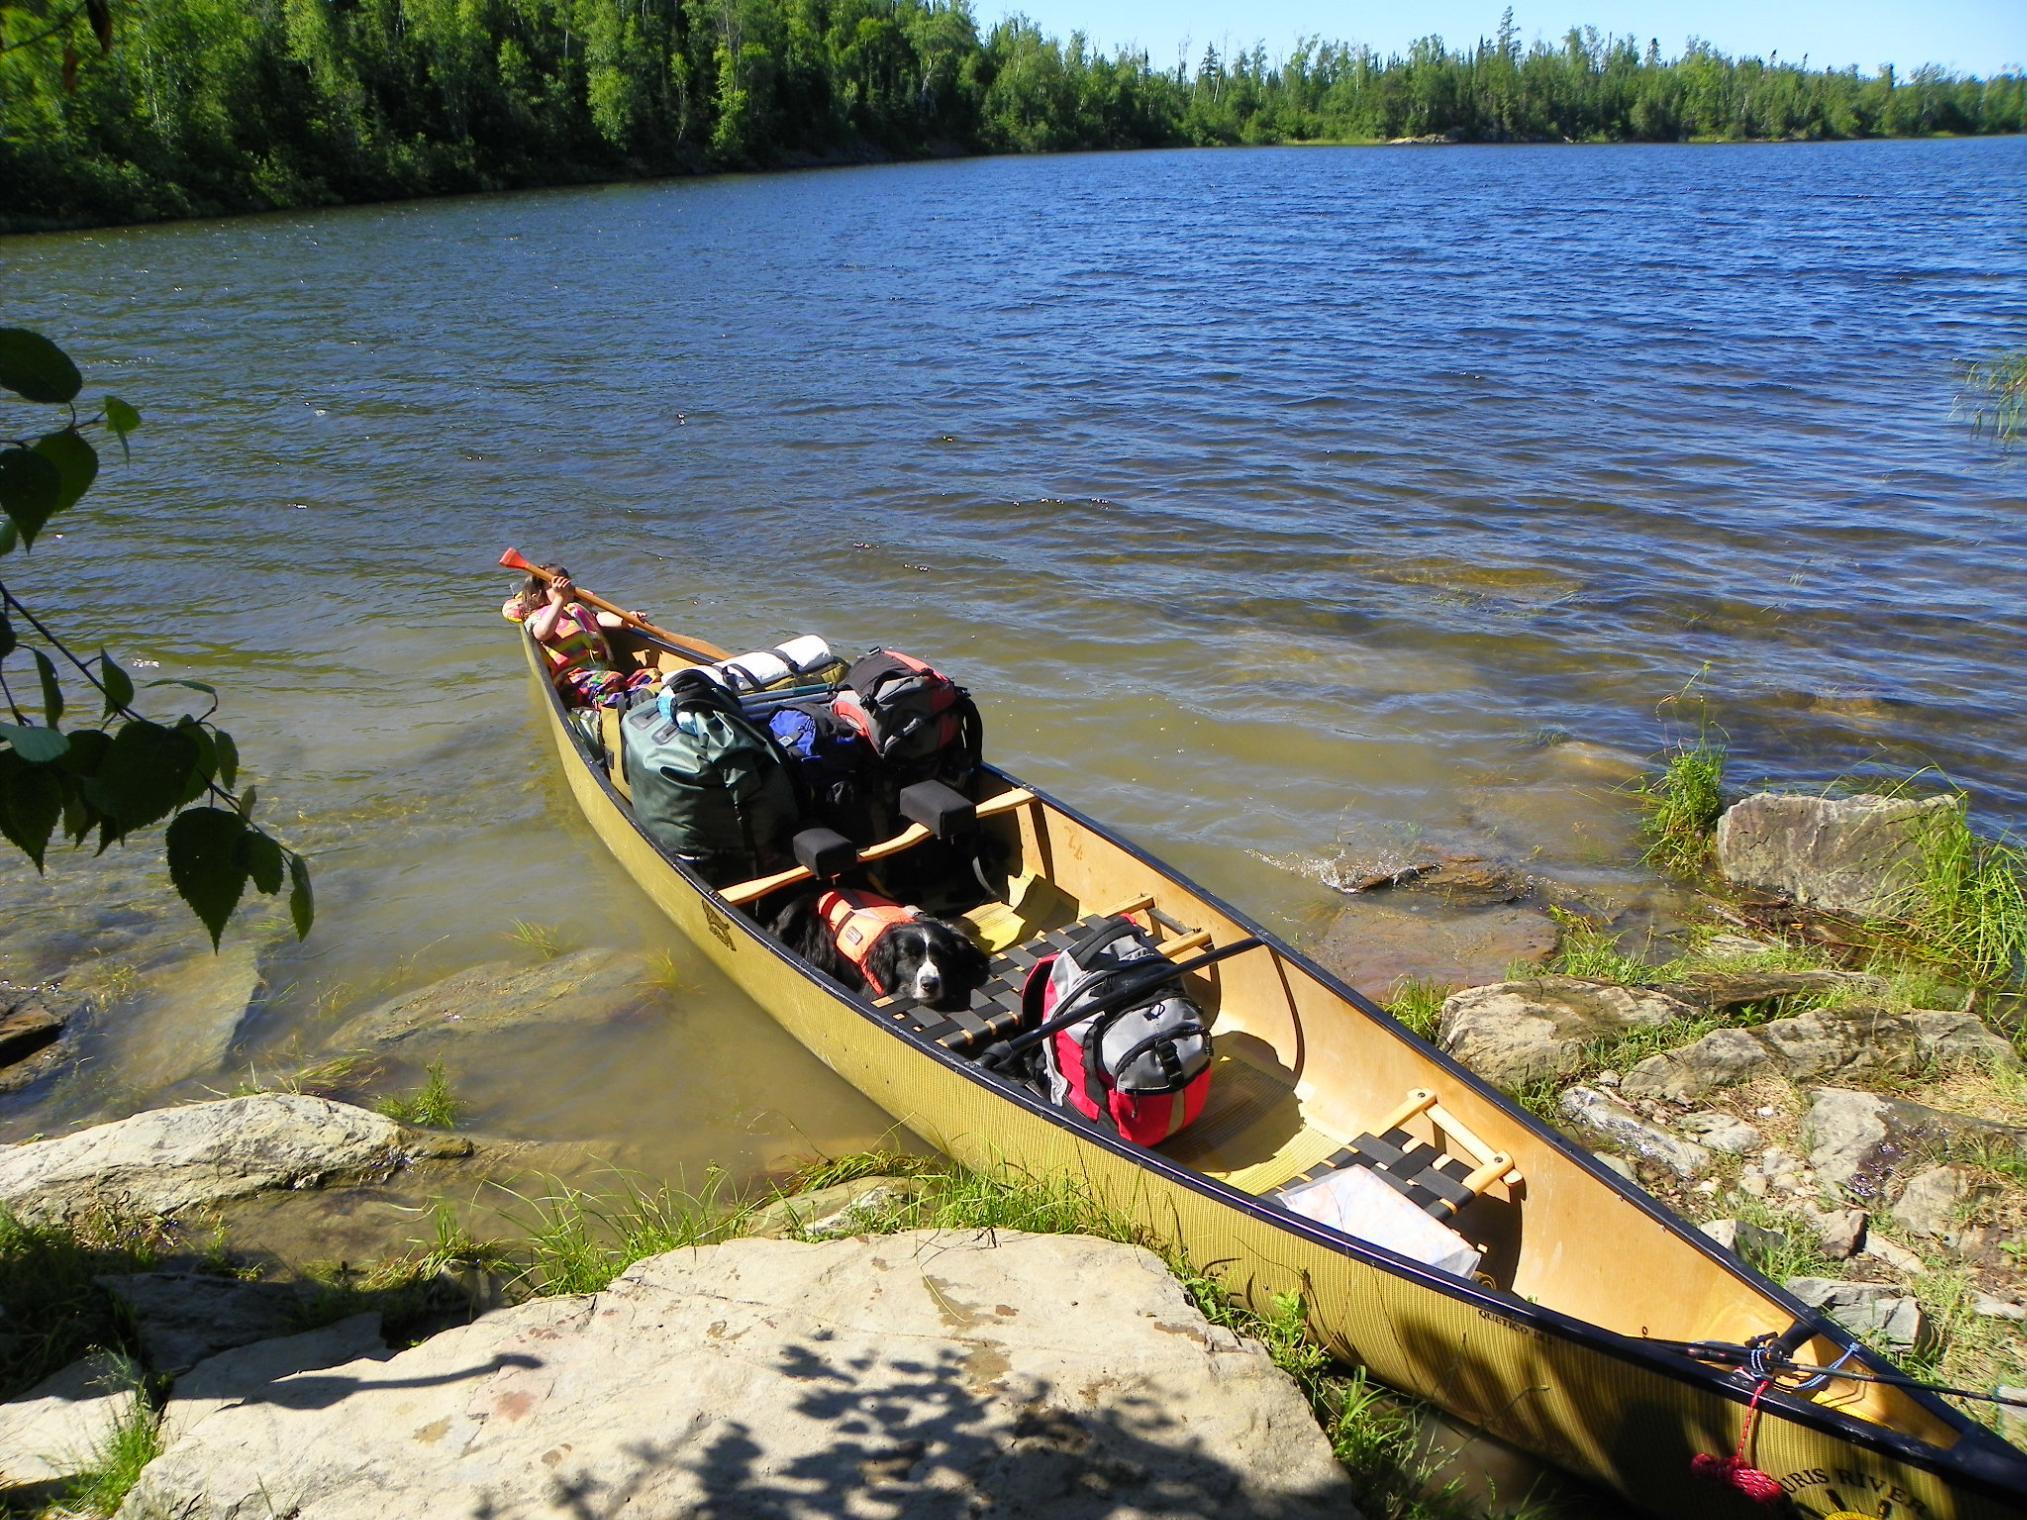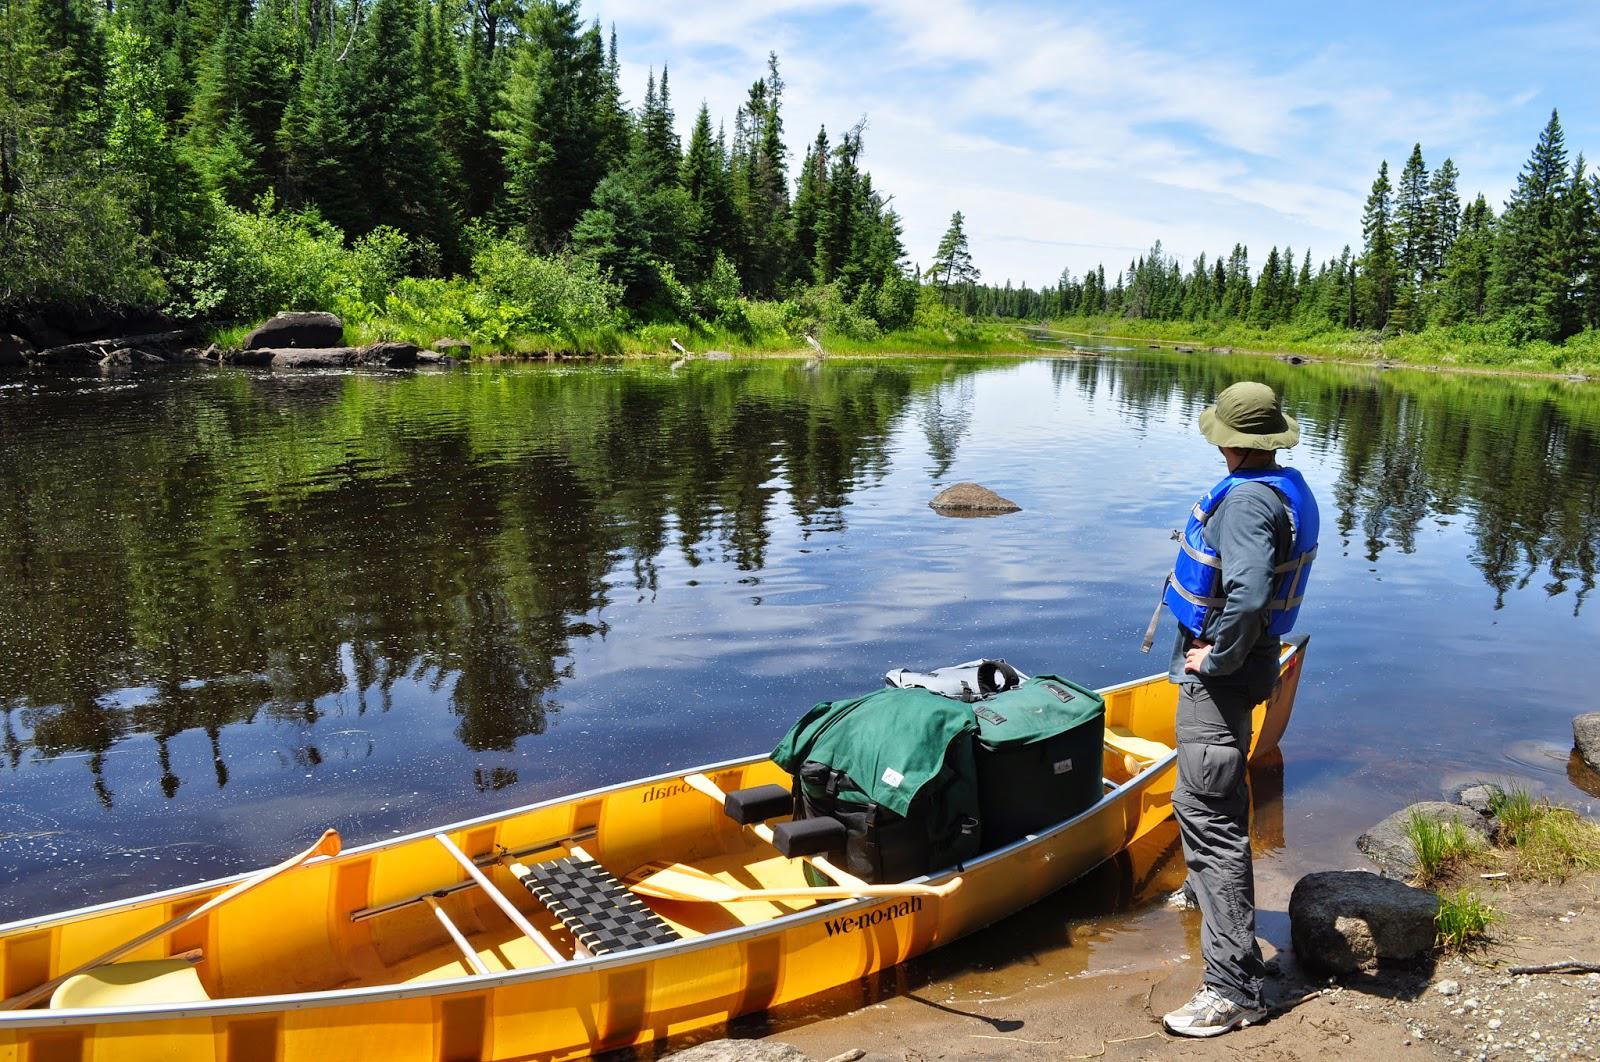The first image is the image on the left, the second image is the image on the right. Evaluate the accuracy of this statement regarding the images: "There are at least four boats in total.". Is it true? Answer yes or no. No. The first image is the image on the left, the second image is the image on the right. Given the left and right images, does the statement "there is a canoe on the beach with a row of tree trunks to the right" hold true? Answer yes or no. No. 